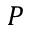<formula> <loc_0><loc_0><loc_500><loc_500>P</formula> 